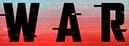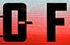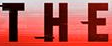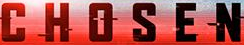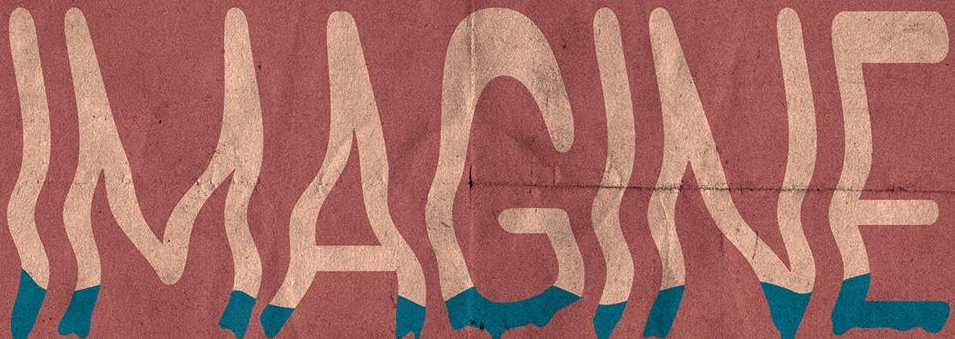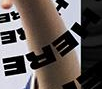Read the text content from these images in order, separated by a semicolon. WAR; OF; THE; CHOSEN; IMAGINE; HERE 